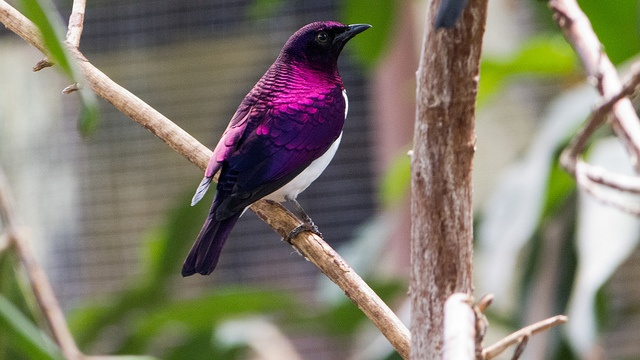Describe the objects in this image and their specific colors. I can see a bird in white, black, navy, purple, and gray tones in this image. 